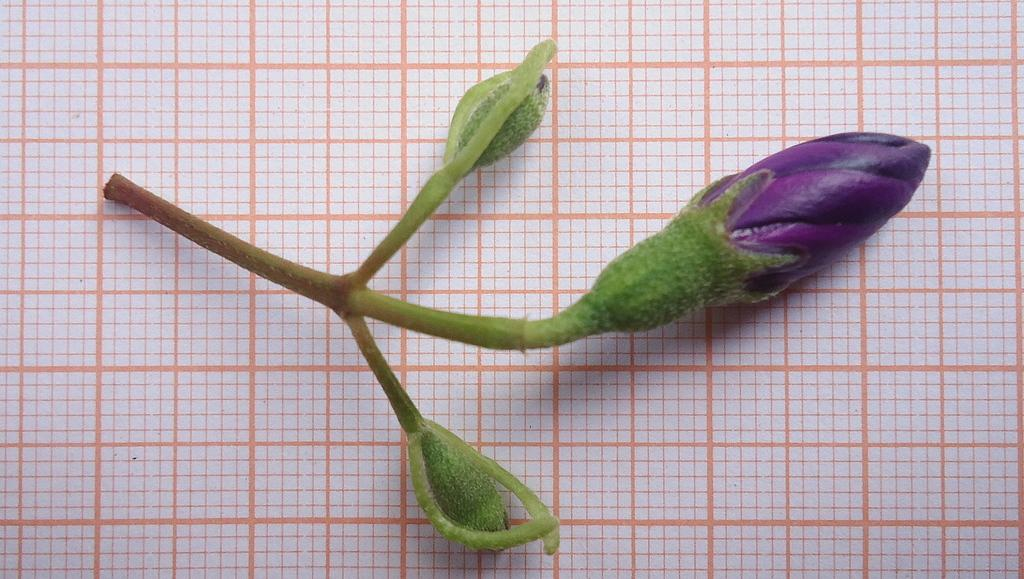What is the main subject of the image? The main subject of the image is a flower bud. Can you describe the color of the flower bud? The flower bud is green and purple in color. Where is the flower bud located in the image? The flower bud is on a paper. What is the color of the paper? The paper is white and orange in color. What type of arithmetic problem is being solved on the paper? There is no arithmetic problem visible in the image; it only features a flower bud on a white and orange paper. 